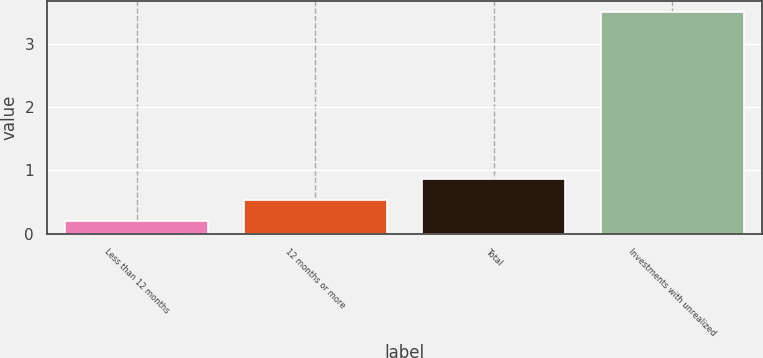<chart> <loc_0><loc_0><loc_500><loc_500><bar_chart><fcel>Less than 12 months<fcel>12 months or more<fcel>Total<fcel>Investments with unrealized<nl><fcel>0.2<fcel>0.53<fcel>0.86<fcel>3.5<nl></chart> 